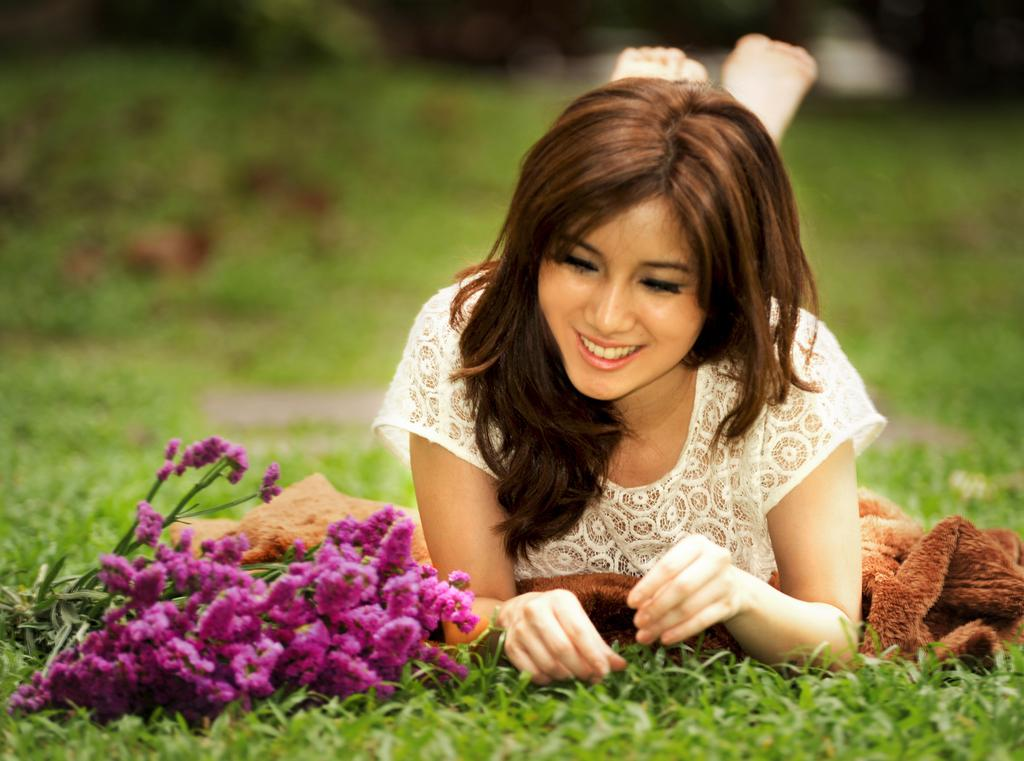What is the woman doing in the image? The woman is lying on the garden. What is the woman wearing in the image? The woman is wearing a white dress. What type of flowers can be seen in the garden? There are purple flowers in the garden. What is the color of the grass in the garden? The grass in the garden is green. What other object can be seen in the image? There is a brown cloth visible in the image. What verse is the woman reciting in the image? There is no indication in the image that the woman is reciting a verse. 